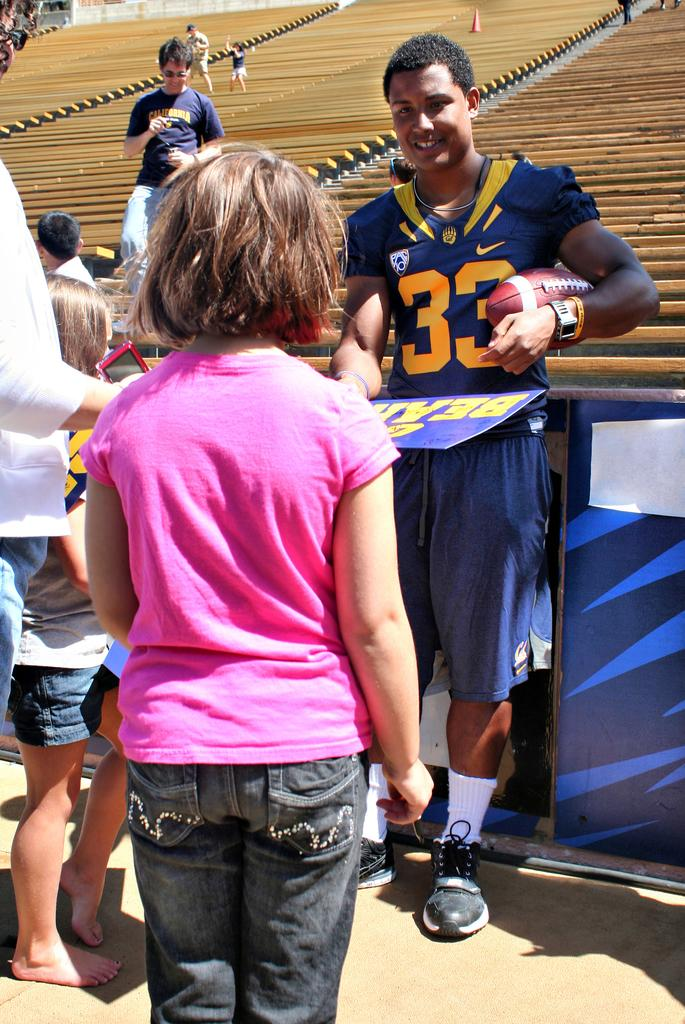<image>
Render a clear and concise summary of the photo. A man in a football jersey holding a sign that says bears. 